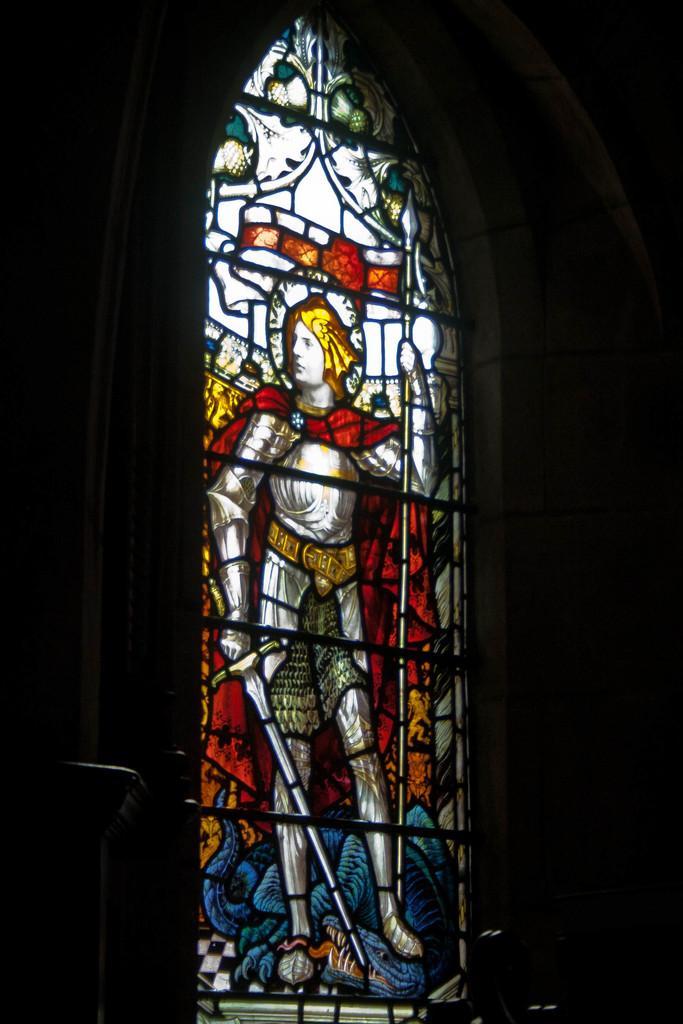How would you summarize this image in a sentence or two? In this image we can see a wall and a glass. On the glass we can see the image of a person holding objects. 